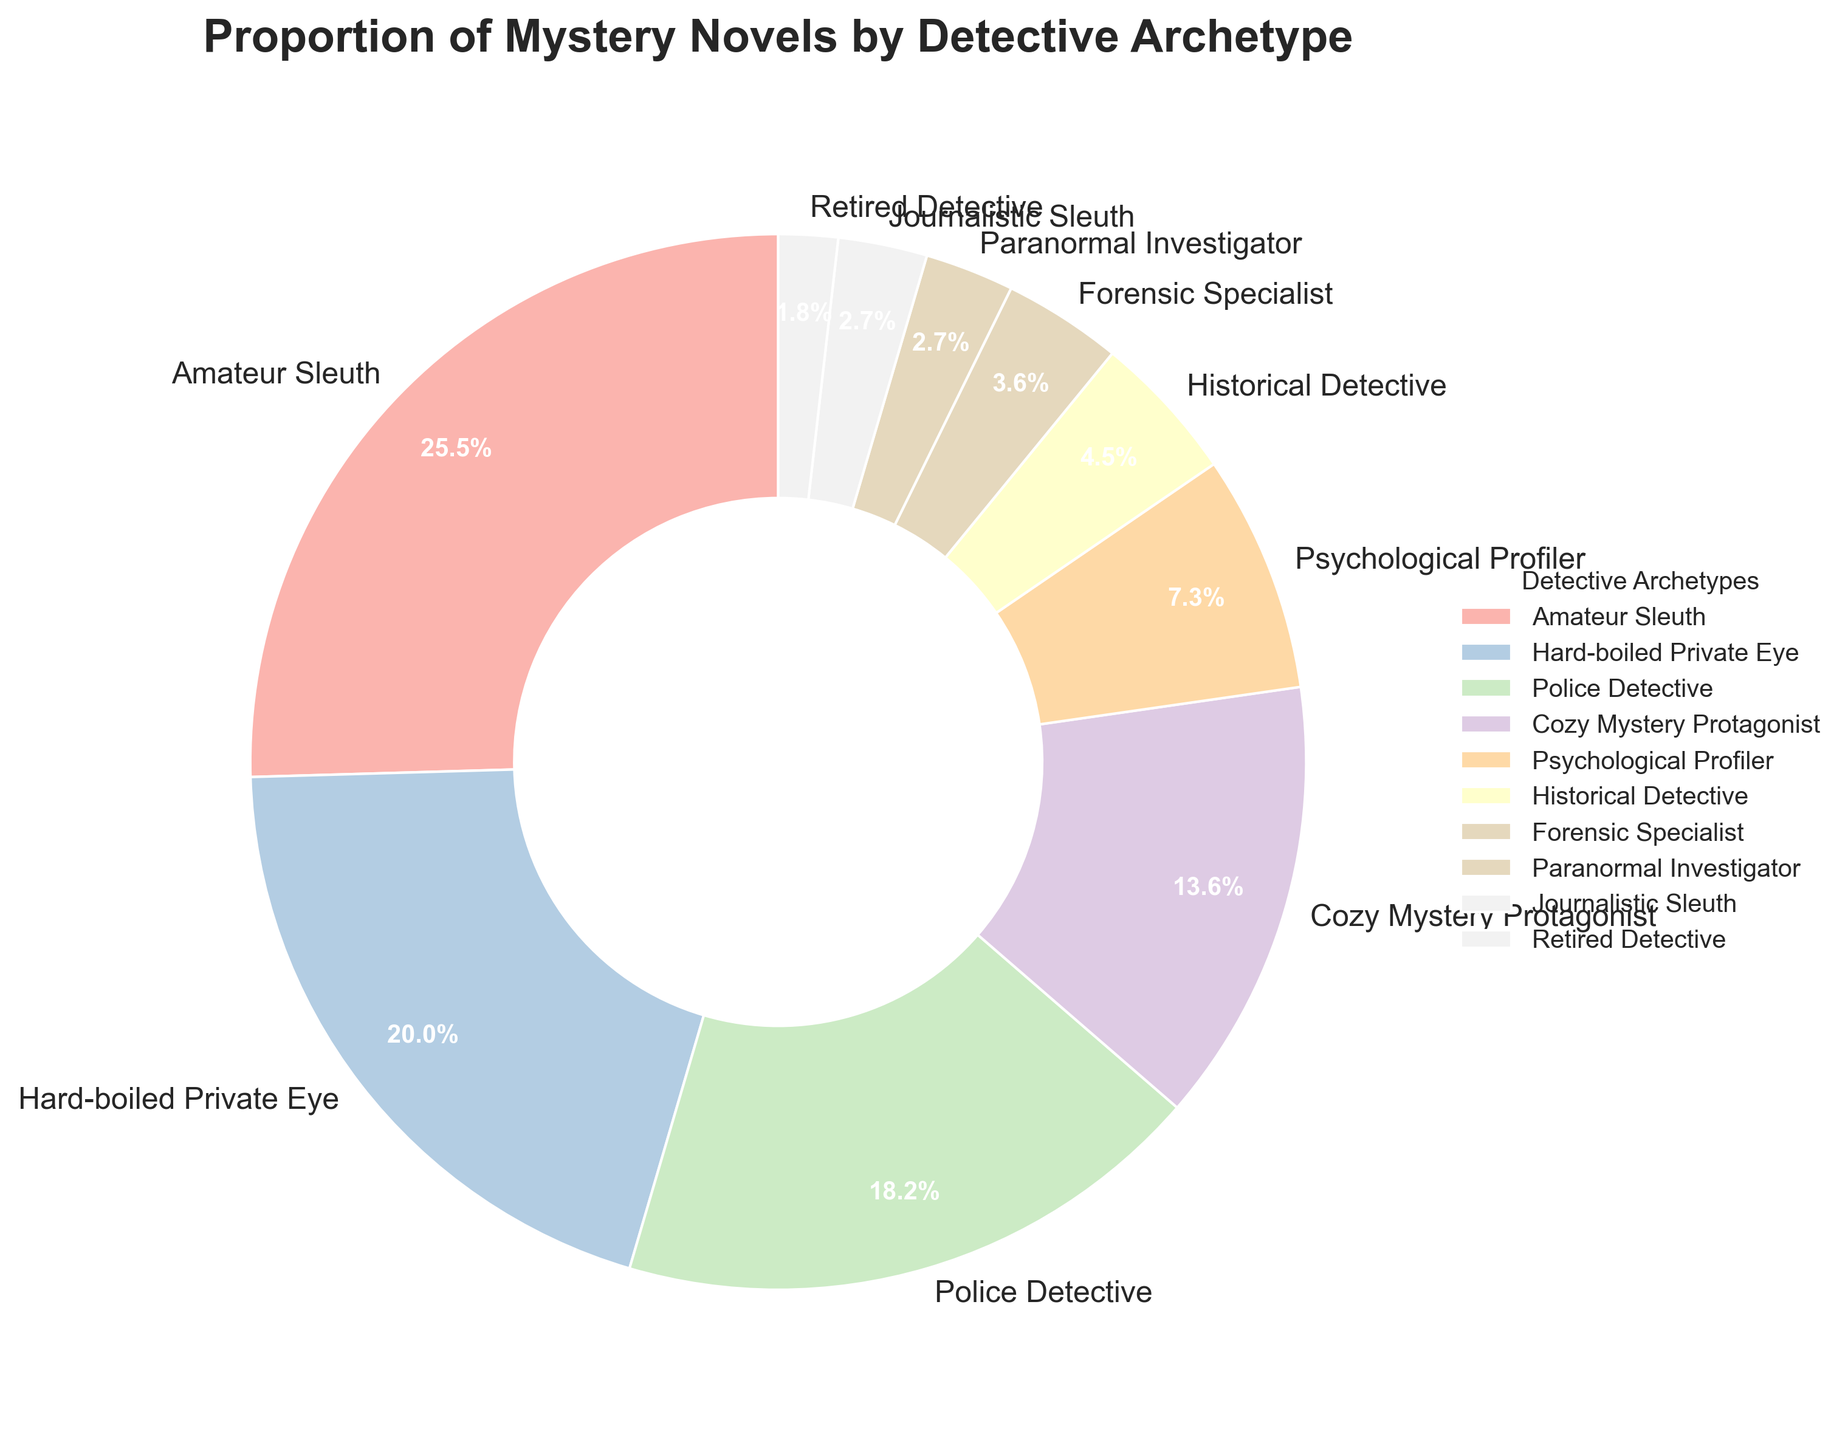What percentage of mystery novels feature an Amateur Sleuth? Find the segment labeled "Amateur Sleuth" in the pie chart. The label indicates a value of 28%.
Answer: 28% Which detective archetype appears more frequently than Police Detective but less frequently than Amateur Sleuth? First identify the percentages for Police Detective and Amateur Sleuth, which are 20% and 28%, respectively. Then find the detective archetype with a percentage between these two values, which is Hard-boiled Private Eye at 22%.
Answer: Hard-boiled Private Eye How many detective archetypes feature in less than 5% of mystery novels? Identify the segments with percentages less than 5%: Forensic Specialist (4%), Paranormal Investigator (3%), Journalistic Sleuth (3%), and Retired Detective (2%). Count these segments, which totals to 4.
Answer: 4 What is the combined percentage of mystery novels featuring Cozy Mystery Protagonist and Psychological Profiler? Find the percentages for Cozy Mystery Protagonist (15%) and Psychological Profiler (8%), then add them together: 15% + 8% = 23%.
Answer: 23% Which detective archetype has the smallest representation in the pie chart? Identify the segment with the smallest percentage, which is Retired Detective at 2%.
Answer: Retired Detective Are there more mystery novels featuring Paranormal Investigators or Historical Detectives? Find the percentages for Paranormal Investigator (3%) and Historical Detective (5%). Since 5% is greater than 3%, Historical Detective appears more frequently.
Answer: Historical Detective What is the percentage difference between Forensic Specialist and Hard-boiled Private Eye? Locate the percentages for Forensic Specialist (4%) and Hard-boiled Private Eye (22%). Subtract the smaller percentage from the larger one: 22% - 4% = 18%.
Answer: 18% How do the proportions of novels featuring Police Detectives and Cozy Mystery Protagonists compare? Identify the percentages for Police Detective (20%) and Cozy Mystery Protagonist (15%). Since 20% is greater than 15%, Police Detectives feature more frequently.
Answer: Police Detectives feature more frequently If you combine the percentages of novels featuring Retired Detective, Journalistic Sleuth, and Paranormal Investigator, what is the total? Identify the percentages for Retired Detective (2%), Journalistic Sleuth (3%), and Paranormal Investigator (3%), then add them together: 2% + 3% + 3% = 8%.
Answer: 8% 